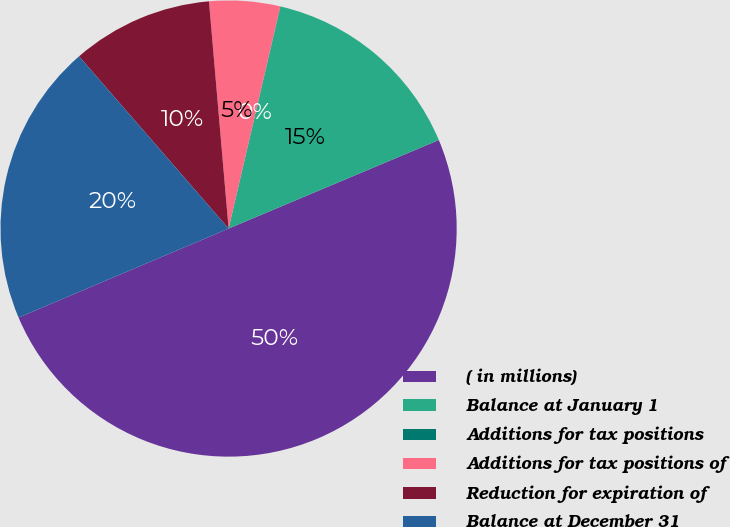<chart> <loc_0><loc_0><loc_500><loc_500><pie_chart><fcel>( in millions)<fcel>Balance at January 1<fcel>Additions for tax positions<fcel>Additions for tax positions of<fcel>Reduction for expiration of<fcel>Balance at December 31<nl><fcel>49.97%<fcel>15.0%<fcel>0.02%<fcel>5.01%<fcel>10.01%<fcel>20.0%<nl></chart> 